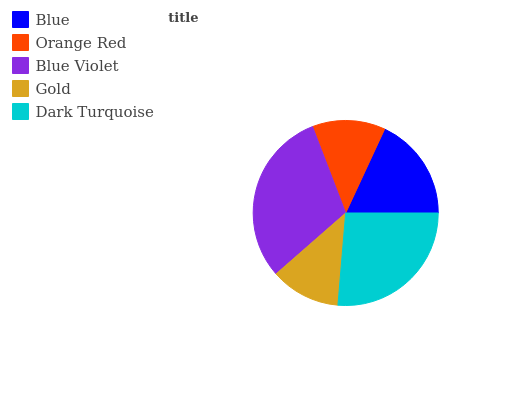Is Gold the minimum?
Answer yes or no. Yes. Is Blue Violet the maximum?
Answer yes or no. Yes. Is Orange Red the minimum?
Answer yes or no. No. Is Orange Red the maximum?
Answer yes or no. No. Is Blue greater than Orange Red?
Answer yes or no. Yes. Is Orange Red less than Blue?
Answer yes or no. Yes. Is Orange Red greater than Blue?
Answer yes or no. No. Is Blue less than Orange Red?
Answer yes or no. No. Is Blue the high median?
Answer yes or no. Yes. Is Blue the low median?
Answer yes or no. Yes. Is Gold the high median?
Answer yes or no. No. Is Gold the low median?
Answer yes or no. No. 